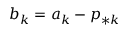<formula> <loc_0><loc_0><loc_500><loc_500>b _ { k } = a _ { k } - p _ { * k }</formula> 